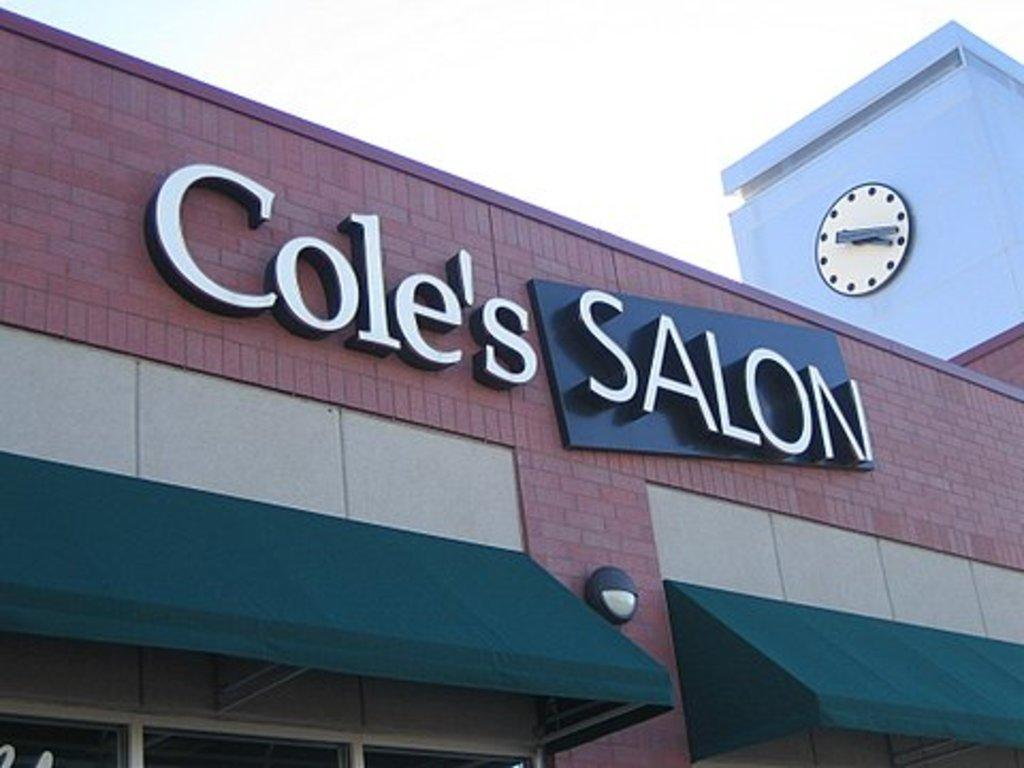Provide a one-sentence caption for the provided image. Cole's Salon building with a clock above it. 